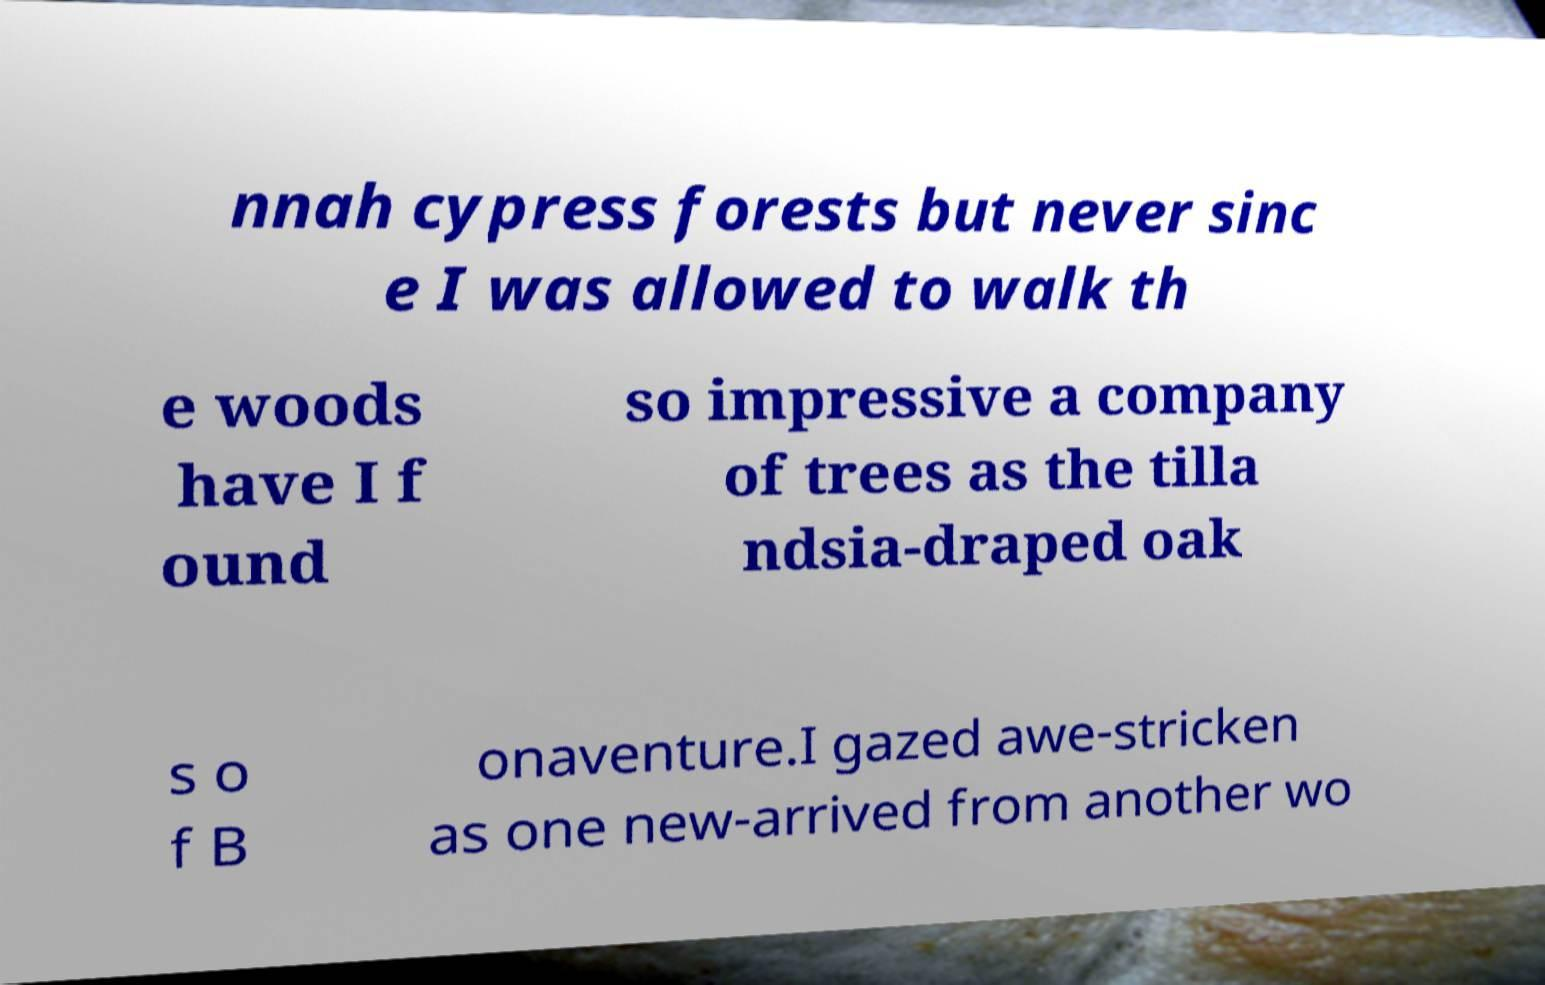Can you accurately transcribe the text from the provided image for me? nnah cypress forests but never sinc e I was allowed to walk th e woods have I f ound so impressive a company of trees as the tilla ndsia-draped oak s o f B onaventure.I gazed awe-stricken as one new-arrived from another wo 